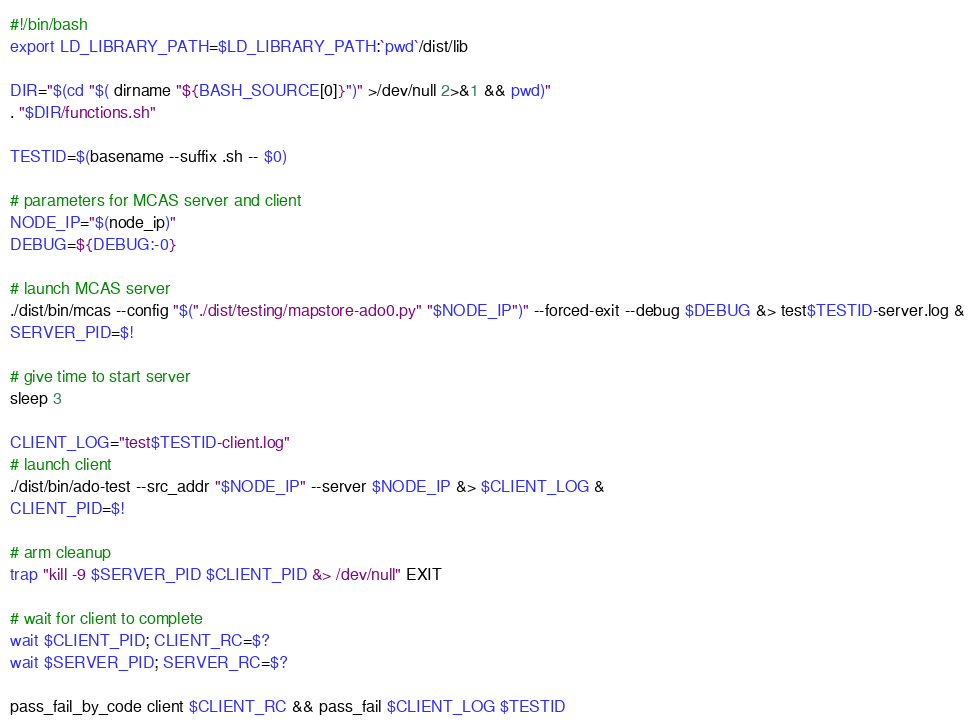<code> <loc_0><loc_0><loc_500><loc_500><_Bash_>#!/bin/bash
export LD_LIBRARY_PATH=$LD_LIBRARY_PATH:`pwd`/dist/lib

DIR="$(cd "$( dirname "${BASH_SOURCE[0]}")" >/dev/null 2>&1 && pwd)"
. "$DIR/functions.sh"

TESTID=$(basename --suffix .sh -- $0)

# parameters for MCAS server and client
NODE_IP="$(node_ip)"
DEBUG=${DEBUG:-0}

# launch MCAS server
./dist/bin/mcas --config "$("./dist/testing/mapstore-ado0.py" "$NODE_IP")" --forced-exit --debug $DEBUG &> test$TESTID-server.log &
SERVER_PID=$!

# give time to start server
sleep 3

CLIENT_LOG="test$TESTID-client.log"
# launch client
./dist/bin/ado-test --src_addr "$NODE_IP" --server $NODE_IP &> $CLIENT_LOG &
CLIENT_PID=$!

# arm cleanup
trap "kill -9 $SERVER_PID $CLIENT_PID &> /dev/null" EXIT

# wait for client to complete
wait $CLIENT_PID; CLIENT_RC=$?
wait $SERVER_PID; SERVER_RC=$?

pass_fail_by_code client $CLIENT_RC && pass_fail $CLIENT_LOG $TESTID
</code> 